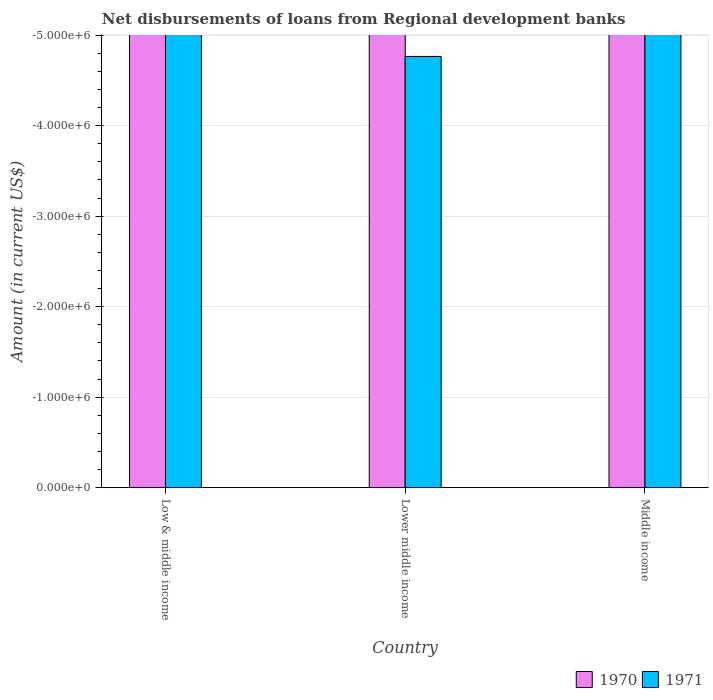How many different coloured bars are there?
Your answer should be very brief. 0. Are the number of bars per tick equal to the number of legend labels?
Provide a short and direct response. No. Are the number of bars on each tick of the X-axis equal?
Provide a succinct answer. Yes. How many bars are there on the 3rd tick from the left?
Offer a terse response. 0. How many bars are there on the 2nd tick from the right?
Offer a very short reply. 0. What is the amount of disbursements of loans from regional development banks in 1970 in Low & middle income?
Make the answer very short. 0. Across all countries, what is the minimum amount of disbursements of loans from regional development banks in 1971?
Provide a short and direct response. 0. What is the total amount of disbursements of loans from regional development banks in 1971 in the graph?
Your response must be concise. 0. What is the difference between the amount of disbursements of loans from regional development banks in 1970 in Lower middle income and the amount of disbursements of loans from regional development banks in 1971 in Low & middle income?
Your answer should be compact. 0. What is the average amount of disbursements of loans from regional development banks in 1970 per country?
Your answer should be compact. 0. In how many countries, is the amount of disbursements of loans from regional development banks in 1970 greater than the average amount of disbursements of loans from regional development banks in 1970 taken over all countries?
Make the answer very short. 0. Are all the bars in the graph horizontal?
Provide a short and direct response. No. How many countries are there in the graph?
Provide a short and direct response. 3. What is the difference between two consecutive major ticks on the Y-axis?
Your response must be concise. 1.00e+06. Does the graph contain any zero values?
Offer a terse response. Yes. What is the title of the graph?
Keep it short and to the point. Net disbursements of loans from Regional development banks. What is the label or title of the Y-axis?
Provide a short and direct response. Amount (in current US$). What is the Amount (in current US$) of 1971 in Low & middle income?
Give a very brief answer. 0. What is the total Amount (in current US$) of 1970 in the graph?
Your answer should be very brief. 0. What is the average Amount (in current US$) of 1971 per country?
Offer a very short reply. 0. 